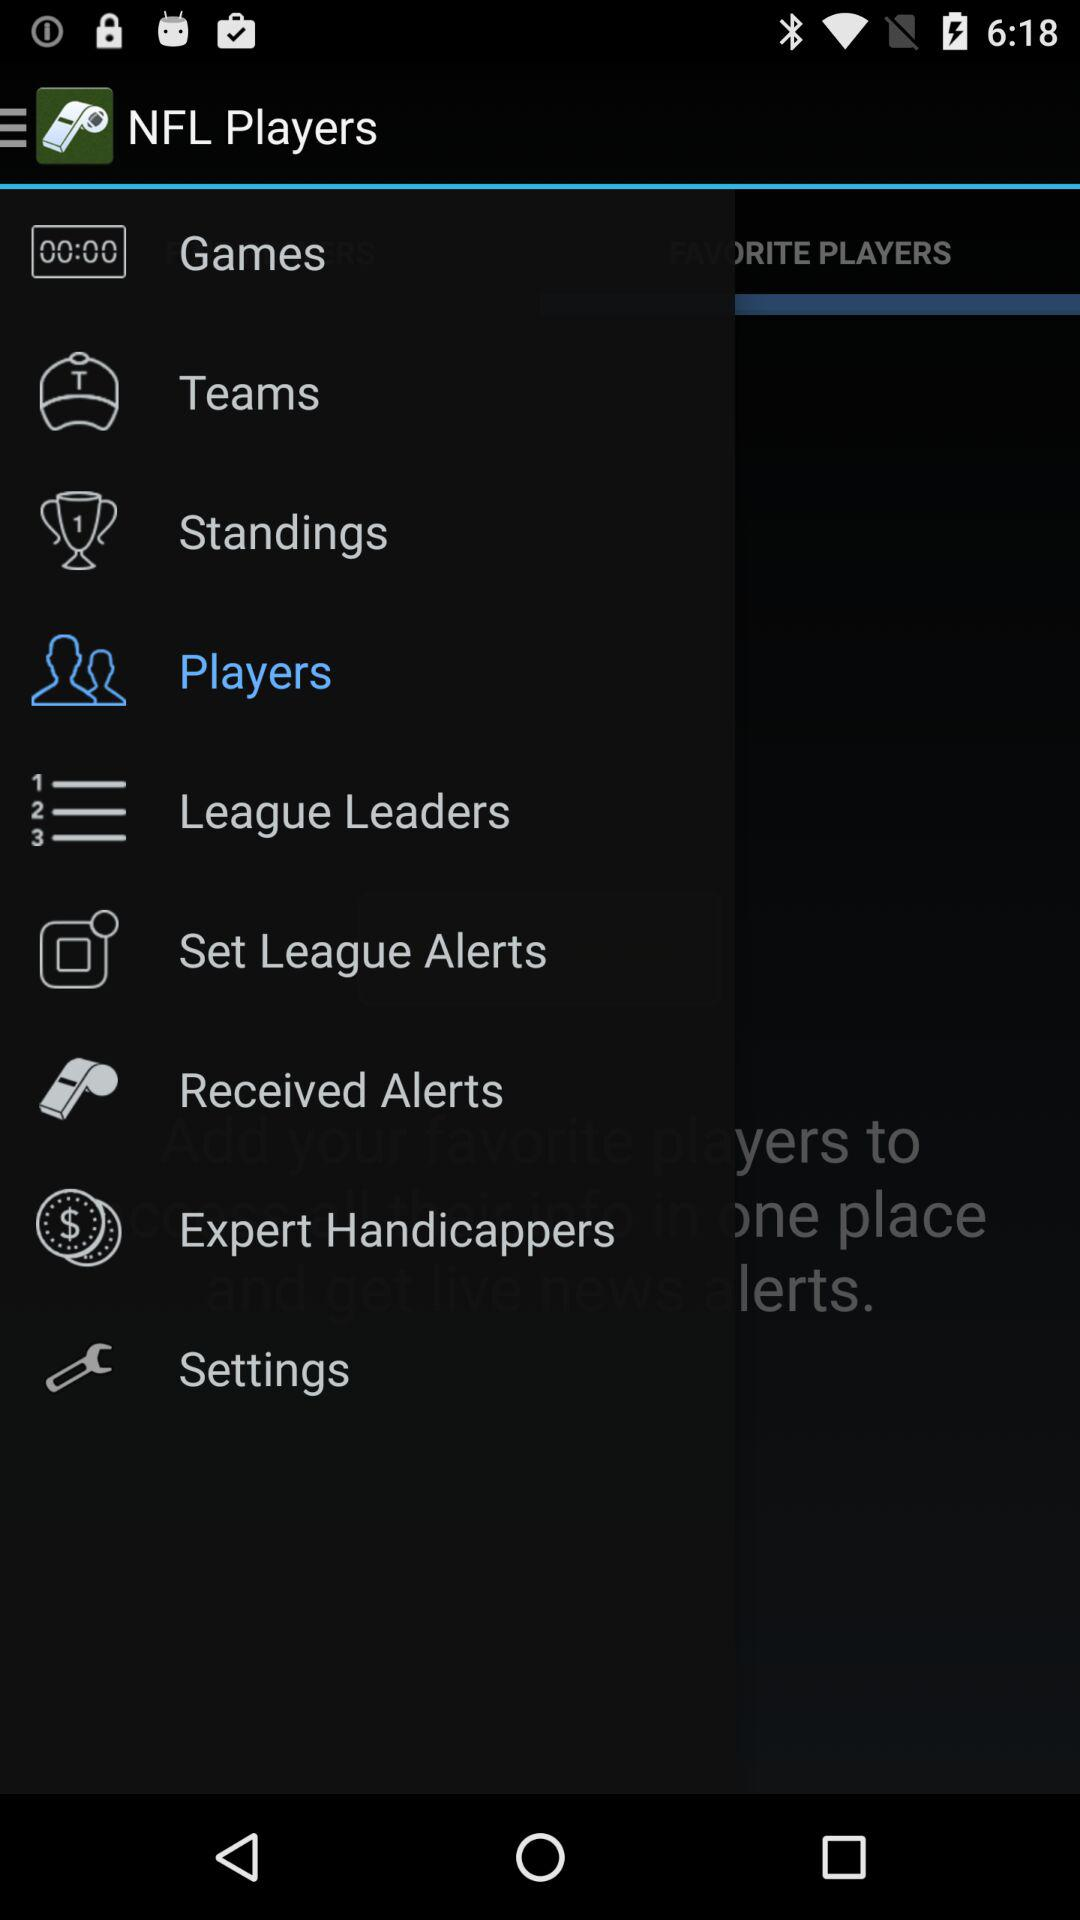How long ago was the last update?
When the provided information is insufficient, respond with <no answer>. <no answer> 